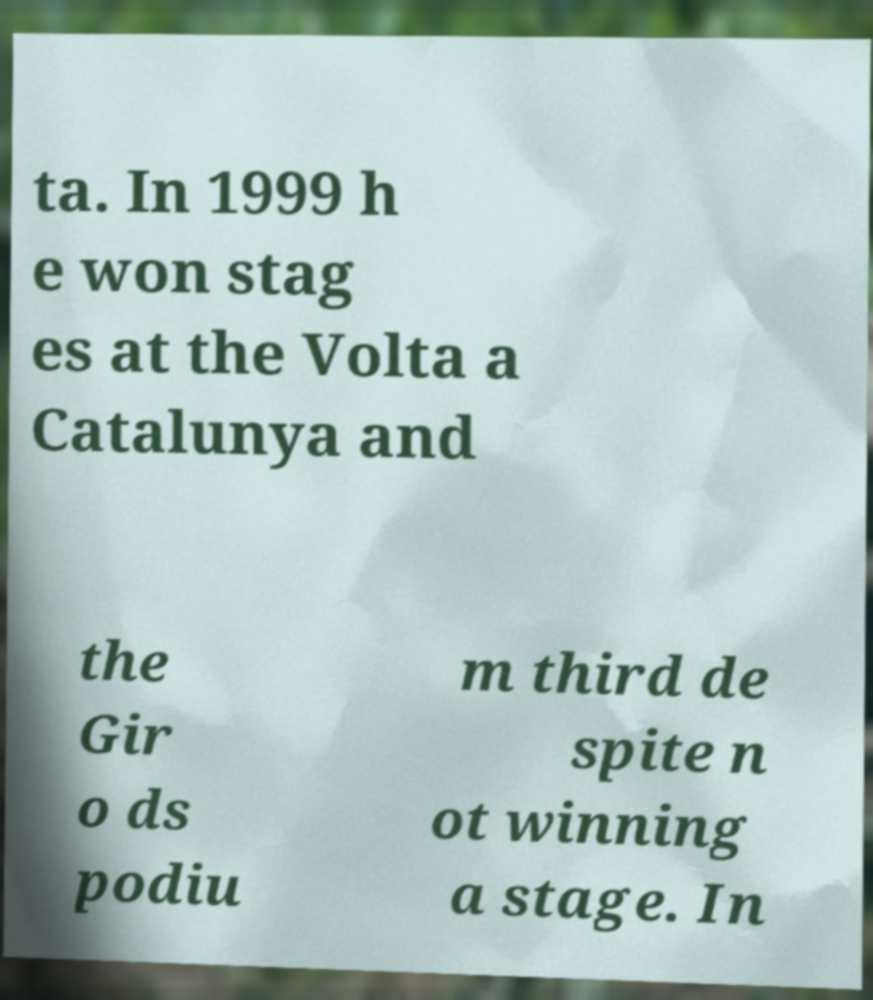Can you read and provide the text displayed in the image?This photo seems to have some interesting text. Can you extract and type it out for me? ta. In 1999 h e won stag es at the Volta a Catalunya and the Gir o ds podiu m third de spite n ot winning a stage. In 